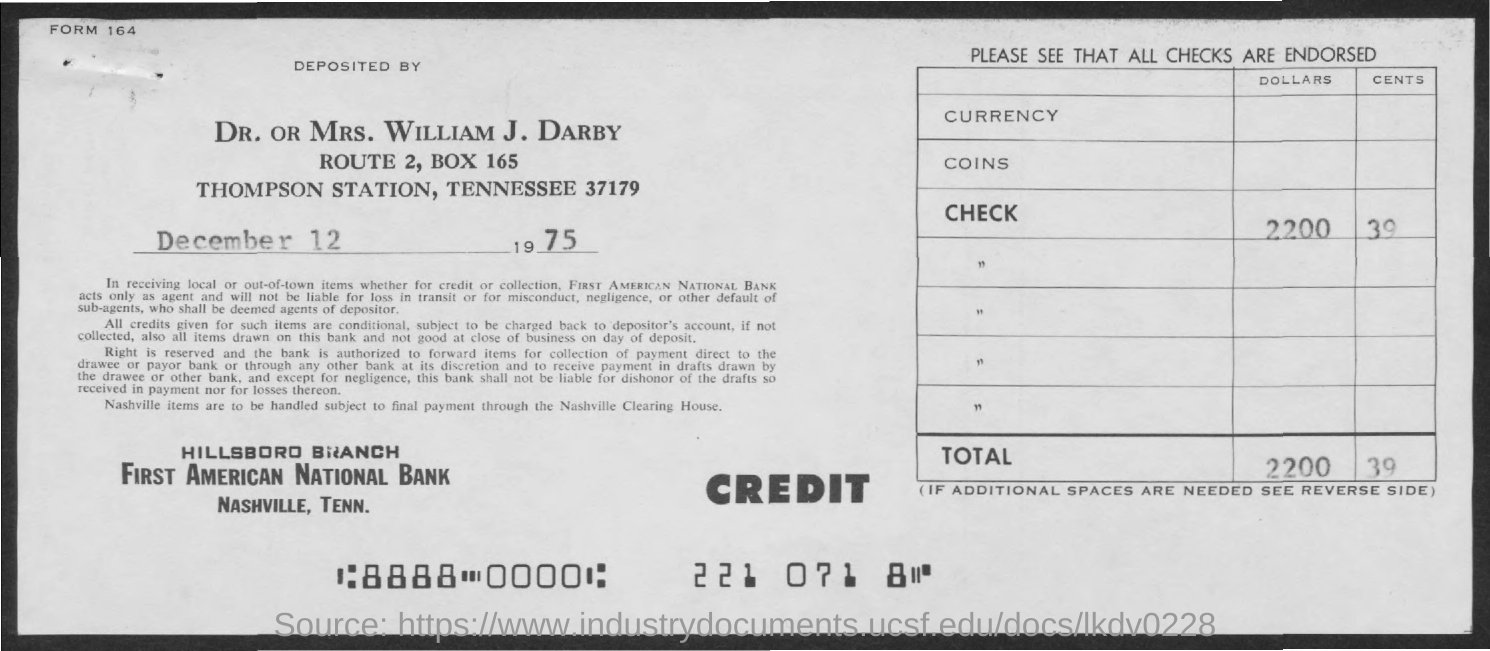What is the Box number?
Make the answer very short. 165. What is date mentioned in the document ?
Your response must be concise. December 12, 1975. 